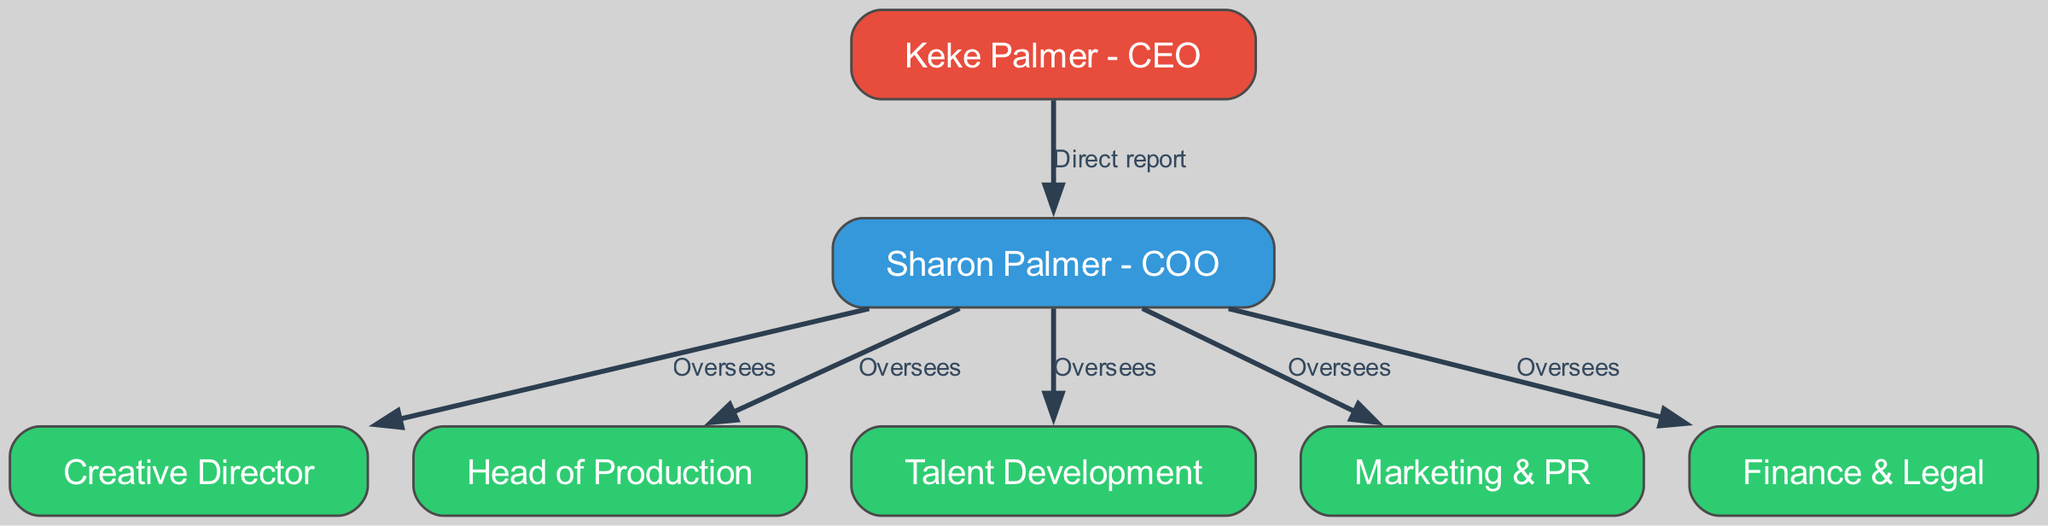What is the role of Keke Palmer in Big Boss Entertainment? Keke Palmer is labeled as the CEO in the diagram, indicating her top leadership position within the company.
Answer: CEO How many positions report directly to the COO? The COO oversees five different roles as shown by the edges branching from the COO node to other positions in the diagram.
Answer: 5 Which node represents the Marketing department? The node labeled "Marketing & PR" corresponds to the Marketing department, specifically identified in the diagram.
Answer: Marketing & PR Who oversees the Head of Production? The COO is connected to the Head of Production by a directed edge labeled "Oversees," indicating that the COO is responsible for this position.
Answer: COO What is the relationship between the COO and the Creative Director? The COO oversees the Creative Director, as indicated by the directed edge labeled "Oversees" linking these two nodes in the diagram.
Answer: Oversees Which position is at the top of the organizational structure? The diagram lists Keke Palmer as the CEO at the top, indicating her primary authoritative role in the company's structure.
Answer: Keke Palmer How many total nodes are in the diagram? By counting all the distinct roles represented in the nodes section of the diagram, there are six positions.
Answer: 6 Which position does Sharon Palmer hold? Sharon Palmer is identified as the COO in the diagram, which positions her as the second-in-command under the CEO.
Answer: COO Which departments does the COO oversee? The COO oversees the Creative Director, Head of Production, Talent Development, Marketing & PR, and Finance & Legal, as can be seen from the edges emanating from the COO node.
Answer: Creative Director, Head of Production, Talent Development, Marketing & PR, Finance & Legal 